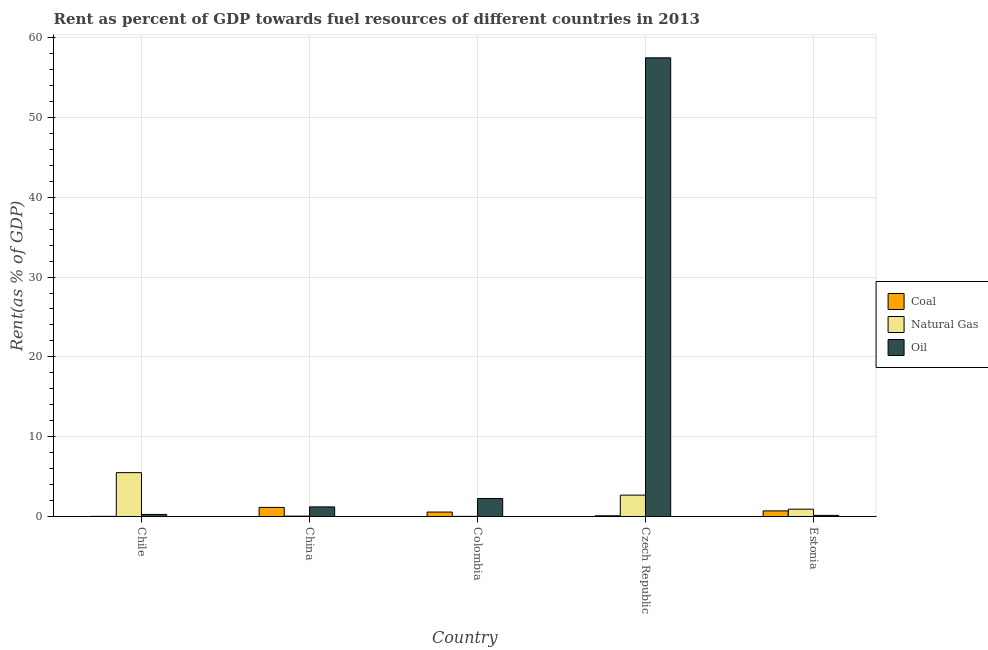How many groups of bars are there?
Your answer should be compact. 5. Are the number of bars per tick equal to the number of legend labels?
Your answer should be compact. Yes. Are the number of bars on each tick of the X-axis equal?
Your response must be concise. Yes. How many bars are there on the 4th tick from the left?
Your answer should be very brief. 3. How many bars are there on the 5th tick from the right?
Your response must be concise. 3. What is the label of the 1st group of bars from the left?
Your answer should be compact. Chile. In how many cases, is the number of bars for a given country not equal to the number of legend labels?
Your response must be concise. 0. What is the rent towards oil in Chile?
Give a very brief answer. 0.26. Across all countries, what is the maximum rent towards natural gas?
Your answer should be very brief. 5.5. Across all countries, what is the minimum rent towards coal?
Keep it short and to the point. 0.02. In which country was the rent towards oil maximum?
Provide a succinct answer. Czech Republic. In which country was the rent towards oil minimum?
Ensure brevity in your answer.  Estonia. What is the total rent towards coal in the graph?
Keep it short and to the point. 2.5. What is the difference between the rent towards oil in Colombia and that in Estonia?
Your response must be concise. 2.12. What is the difference between the rent towards natural gas in China and the rent towards oil in Colombia?
Ensure brevity in your answer.  -2.21. What is the average rent towards natural gas per country?
Ensure brevity in your answer.  1.83. What is the difference between the rent towards coal and rent towards oil in Colombia?
Ensure brevity in your answer.  -1.7. What is the ratio of the rent towards natural gas in China to that in Estonia?
Offer a terse response. 0.05. Is the rent towards oil in Czech Republic less than that in Estonia?
Ensure brevity in your answer.  No. What is the difference between the highest and the second highest rent towards natural gas?
Give a very brief answer. 2.82. What is the difference between the highest and the lowest rent towards oil?
Provide a short and direct response. 57.33. Is the sum of the rent towards oil in Chile and China greater than the maximum rent towards natural gas across all countries?
Offer a very short reply. No. What does the 2nd bar from the left in Chile represents?
Your answer should be compact. Natural Gas. What does the 2nd bar from the right in Estonia represents?
Ensure brevity in your answer.  Natural Gas. Is it the case that in every country, the sum of the rent towards coal and rent towards natural gas is greater than the rent towards oil?
Provide a short and direct response. No. What is the difference between two consecutive major ticks on the Y-axis?
Your response must be concise. 10. Are the values on the major ticks of Y-axis written in scientific E-notation?
Ensure brevity in your answer.  No. Does the graph contain any zero values?
Your answer should be very brief. No. Does the graph contain grids?
Your answer should be compact. Yes. Where does the legend appear in the graph?
Offer a terse response. Center right. How are the legend labels stacked?
Offer a terse response. Vertical. What is the title of the graph?
Keep it short and to the point. Rent as percent of GDP towards fuel resources of different countries in 2013. Does "Domestic economy" appear as one of the legend labels in the graph?
Your response must be concise. No. What is the label or title of the Y-axis?
Your answer should be very brief. Rent(as % of GDP). What is the Rent(as % of GDP) in Coal in Chile?
Provide a short and direct response. 0.02. What is the Rent(as % of GDP) of Natural Gas in Chile?
Make the answer very short. 5.5. What is the Rent(as % of GDP) in Oil in Chile?
Ensure brevity in your answer.  0.26. What is the Rent(as % of GDP) in Coal in China?
Your answer should be very brief. 1.14. What is the Rent(as % of GDP) of Natural Gas in China?
Offer a terse response. 0.05. What is the Rent(as % of GDP) of Oil in China?
Offer a very short reply. 1.2. What is the Rent(as % of GDP) in Coal in Colombia?
Provide a short and direct response. 0.56. What is the Rent(as % of GDP) of Natural Gas in Colombia?
Keep it short and to the point. 0.02. What is the Rent(as % of GDP) in Oil in Colombia?
Your answer should be compact. 2.26. What is the Rent(as % of GDP) of Coal in Czech Republic?
Provide a succinct answer. 0.09. What is the Rent(as % of GDP) of Natural Gas in Czech Republic?
Provide a succinct answer. 2.68. What is the Rent(as % of GDP) of Oil in Czech Republic?
Keep it short and to the point. 57.47. What is the Rent(as % of GDP) of Coal in Estonia?
Offer a terse response. 0.7. What is the Rent(as % of GDP) in Natural Gas in Estonia?
Your response must be concise. 0.92. What is the Rent(as % of GDP) in Oil in Estonia?
Provide a succinct answer. 0.14. Across all countries, what is the maximum Rent(as % of GDP) in Coal?
Your answer should be compact. 1.14. Across all countries, what is the maximum Rent(as % of GDP) of Natural Gas?
Your response must be concise. 5.5. Across all countries, what is the maximum Rent(as % of GDP) of Oil?
Provide a succinct answer. 57.47. Across all countries, what is the minimum Rent(as % of GDP) of Coal?
Give a very brief answer. 0.02. Across all countries, what is the minimum Rent(as % of GDP) of Natural Gas?
Provide a succinct answer. 0.02. Across all countries, what is the minimum Rent(as % of GDP) of Oil?
Keep it short and to the point. 0.14. What is the total Rent(as % of GDP) in Coal in the graph?
Offer a very short reply. 2.5. What is the total Rent(as % of GDP) of Natural Gas in the graph?
Give a very brief answer. 9.15. What is the total Rent(as % of GDP) in Oil in the graph?
Provide a short and direct response. 61.33. What is the difference between the Rent(as % of GDP) in Coal in Chile and that in China?
Offer a terse response. -1.12. What is the difference between the Rent(as % of GDP) of Natural Gas in Chile and that in China?
Your answer should be compact. 5.45. What is the difference between the Rent(as % of GDP) in Oil in Chile and that in China?
Offer a very short reply. -0.95. What is the difference between the Rent(as % of GDP) of Coal in Chile and that in Colombia?
Provide a succinct answer. -0.54. What is the difference between the Rent(as % of GDP) in Natural Gas in Chile and that in Colombia?
Give a very brief answer. 5.48. What is the difference between the Rent(as % of GDP) of Oil in Chile and that in Colombia?
Provide a short and direct response. -2. What is the difference between the Rent(as % of GDP) in Coal in Chile and that in Czech Republic?
Provide a succinct answer. -0.07. What is the difference between the Rent(as % of GDP) in Natural Gas in Chile and that in Czech Republic?
Provide a succinct answer. 2.82. What is the difference between the Rent(as % of GDP) of Oil in Chile and that in Czech Republic?
Offer a terse response. -57.22. What is the difference between the Rent(as % of GDP) in Coal in Chile and that in Estonia?
Provide a short and direct response. -0.68. What is the difference between the Rent(as % of GDP) in Natural Gas in Chile and that in Estonia?
Offer a terse response. 4.58. What is the difference between the Rent(as % of GDP) in Oil in Chile and that in Estonia?
Your answer should be compact. 0.12. What is the difference between the Rent(as % of GDP) in Coal in China and that in Colombia?
Your response must be concise. 0.58. What is the difference between the Rent(as % of GDP) of Natural Gas in China and that in Colombia?
Ensure brevity in your answer.  0.03. What is the difference between the Rent(as % of GDP) of Oil in China and that in Colombia?
Offer a very short reply. -1.05. What is the difference between the Rent(as % of GDP) of Coal in China and that in Czech Republic?
Make the answer very short. 1.05. What is the difference between the Rent(as % of GDP) of Natural Gas in China and that in Czech Republic?
Offer a very short reply. -2.63. What is the difference between the Rent(as % of GDP) in Oil in China and that in Czech Republic?
Offer a very short reply. -56.27. What is the difference between the Rent(as % of GDP) in Coal in China and that in Estonia?
Provide a short and direct response. 0.44. What is the difference between the Rent(as % of GDP) of Natural Gas in China and that in Estonia?
Give a very brief answer. -0.87. What is the difference between the Rent(as % of GDP) of Oil in China and that in Estonia?
Make the answer very short. 1.06. What is the difference between the Rent(as % of GDP) in Coal in Colombia and that in Czech Republic?
Your answer should be compact. 0.47. What is the difference between the Rent(as % of GDP) in Natural Gas in Colombia and that in Czech Republic?
Your answer should be compact. -2.66. What is the difference between the Rent(as % of GDP) in Oil in Colombia and that in Czech Republic?
Your answer should be very brief. -55.22. What is the difference between the Rent(as % of GDP) of Coal in Colombia and that in Estonia?
Provide a short and direct response. -0.14. What is the difference between the Rent(as % of GDP) of Natural Gas in Colombia and that in Estonia?
Provide a short and direct response. -0.9. What is the difference between the Rent(as % of GDP) of Oil in Colombia and that in Estonia?
Offer a terse response. 2.12. What is the difference between the Rent(as % of GDP) of Coal in Czech Republic and that in Estonia?
Provide a short and direct response. -0.61. What is the difference between the Rent(as % of GDP) of Natural Gas in Czech Republic and that in Estonia?
Offer a terse response. 1.76. What is the difference between the Rent(as % of GDP) in Oil in Czech Republic and that in Estonia?
Provide a short and direct response. 57.33. What is the difference between the Rent(as % of GDP) in Coal in Chile and the Rent(as % of GDP) in Natural Gas in China?
Your response must be concise. -0.03. What is the difference between the Rent(as % of GDP) in Coal in Chile and the Rent(as % of GDP) in Oil in China?
Offer a terse response. -1.19. What is the difference between the Rent(as % of GDP) in Natural Gas in Chile and the Rent(as % of GDP) in Oil in China?
Ensure brevity in your answer.  4.29. What is the difference between the Rent(as % of GDP) of Coal in Chile and the Rent(as % of GDP) of Oil in Colombia?
Ensure brevity in your answer.  -2.24. What is the difference between the Rent(as % of GDP) of Natural Gas in Chile and the Rent(as % of GDP) of Oil in Colombia?
Your answer should be very brief. 3.24. What is the difference between the Rent(as % of GDP) of Coal in Chile and the Rent(as % of GDP) of Natural Gas in Czech Republic?
Provide a succinct answer. -2.66. What is the difference between the Rent(as % of GDP) in Coal in Chile and the Rent(as % of GDP) in Oil in Czech Republic?
Provide a succinct answer. -57.46. What is the difference between the Rent(as % of GDP) in Natural Gas in Chile and the Rent(as % of GDP) in Oil in Czech Republic?
Provide a short and direct response. -51.98. What is the difference between the Rent(as % of GDP) of Coal in Chile and the Rent(as % of GDP) of Natural Gas in Estonia?
Your response must be concise. -0.9. What is the difference between the Rent(as % of GDP) of Coal in Chile and the Rent(as % of GDP) of Oil in Estonia?
Offer a terse response. -0.12. What is the difference between the Rent(as % of GDP) of Natural Gas in Chile and the Rent(as % of GDP) of Oil in Estonia?
Ensure brevity in your answer.  5.36. What is the difference between the Rent(as % of GDP) in Coal in China and the Rent(as % of GDP) in Natural Gas in Colombia?
Make the answer very short. 1.12. What is the difference between the Rent(as % of GDP) of Coal in China and the Rent(as % of GDP) of Oil in Colombia?
Make the answer very short. -1.12. What is the difference between the Rent(as % of GDP) of Natural Gas in China and the Rent(as % of GDP) of Oil in Colombia?
Your response must be concise. -2.21. What is the difference between the Rent(as % of GDP) in Coal in China and the Rent(as % of GDP) in Natural Gas in Czech Republic?
Offer a very short reply. -1.54. What is the difference between the Rent(as % of GDP) of Coal in China and the Rent(as % of GDP) of Oil in Czech Republic?
Your response must be concise. -56.34. What is the difference between the Rent(as % of GDP) of Natural Gas in China and the Rent(as % of GDP) of Oil in Czech Republic?
Provide a succinct answer. -57.43. What is the difference between the Rent(as % of GDP) in Coal in China and the Rent(as % of GDP) in Natural Gas in Estonia?
Provide a short and direct response. 0.22. What is the difference between the Rent(as % of GDP) of Natural Gas in China and the Rent(as % of GDP) of Oil in Estonia?
Your answer should be compact. -0.09. What is the difference between the Rent(as % of GDP) in Coal in Colombia and the Rent(as % of GDP) in Natural Gas in Czech Republic?
Your answer should be compact. -2.12. What is the difference between the Rent(as % of GDP) in Coal in Colombia and the Rent(as % of GDP) in Oil in Czech Republic?
Your response must be concise. -56.92. What is the difference between the Rent(as % of GDP) of Natural Gas in Colombia and the Rent(as % of GDP) of Oil in Czech Republic?
Your response must be concise. -57.46. What is the difference between the Rent(as % of GDP) in Coal in Colombia and the Rent(as % of GDP) in Natural Gas in Estonia?
Provide a succinct answer. -0.36. What is the difference between the Rent(as % of GDP) in Coal in Colombia and the Rent(as % of GDP) in Oil in Estonia?
Make the answer very short. 0.42. What is the difference between the Rent(as % of GDP) in Natural Gas in Colombia and the Rent(as % of GDP) in Oil in Estonia?
Your response must be concise. -0.12. What is the difference between the Rent(as % of GDP) of Coal in Czech Republic and the Rent(as % of GDP) of Natural Gas in Estonia?
Your response must be concise. -0.83. What is the difference between the Rent(as % of GDP) of Coal in Czech Republic and the Rent(as % of GDP) of Oil in Estonia?
Offer a very short reply. -0.05. What is the difference between the Rent(as % of GDP) in Natural Gas in Czech Republic and the Rent(as % of GDP) in Oil in Estonia?
Offer a very short reply. 2.54. What is the average Rent(as % of GDP) of Coal per country?
Ensure brevity in your answer.  0.5. What is the average Rent(as % of GDP) of Natural Gas per country?
Give a very brief answer. 1.83. What is the average Rent(as % of GDP) in Oil per country?
Your answer should be compact. 12.27. What is the difference between the Rent(as % of GDP) of Coal and Rent(as % of GDP) of Natural Gas in Chile?
Offer a very short reply. -5.48. What is the difference between the Rent(as % of GDP) of Coal and Rent(as % of GDP) of Oil in Chile?
Make the answer very short. -0.24. What is the difference between the Rent(as % of GDP) in Natural Gas and Rent(as % of GDP) in Oil in Chile?
Offer a very short reply. 5.24. What is the difference between the Rent(as % of GDP) of Coal and Rent(as % of GDP) of Natural Gas in China?
Give a very brief answer. 1.09. What is the difference between the Rent(as % of GDP) of Coal and Rent(as % of GDP) of Oil in China?
Your answer should be very brief. -0.07. What is the difference between the Rent(as % of GDP) of Natural Gas and Rent(as % of GDP) of Oil in China?
Provide a succinct answer. -1.16. What is the difference between the Rent(as % of GDP) in Coal and Rent(as % of GDP) in Natural Gas in Colombia?
Ensure brevity in your answer.  0.54. What is the difference between the Rent(as % of GDP) of Coal and Rent(as % of GDP) of Oil in Colombia?
Your response must be concise. -1.7. What is the difference between the Rent(as % of GDP) of Natural Gas and Rent(as % of GDP) of Oil in Colombia?
Ensure brevity in your answer.  -2.24. What is the difference between the Rent(as % of GDP) of Coal and Rent(as % of GDP) of Natural Gas in Czech Republic?
Your response must be concise. -2.59. What is the difference between the Rent(as % of GDP) of Coal and Rent(as % of GDP) of Oil in Czech Republic?
Your answer should be compact. -57.39. What is the difference between the Rent(as % of GDP) of Natural Gas and Rent(as % of GDP) of Oil in Czech Republic?
Provide a short and direct response. -54.8. What is the difference between the Rent(as % of GDP) in Coal and Rent(as % of GDP) in Natural Gas in Estonia?
Provide a succinct answer. -0.22. What is the difference between the Rent(as % of GDP) in Coal and Rent(as % of GDP) in Oil in Estonia?
Give a very brief answer. 0.56. What is the difference between the Rent(as % of GDP) of Natural Gas and Rent(as % of GDP) of Oil in Estonia?
Your answer should be compact. 0.78. What is the ratio of the Rent(as % of GDP) in Coal in Chile to that in China?
Ensure brevity in your answer.  0.01. What is the ratio of the Rent(as % of GDP) of Natural Gas in Chile to that in China?
Provide a short and direct response. 116.85. What is the ratio of the Rent(as % of GDP) in Oil in Chile to that in China?
Your answer should be compact. 0.21. What is the ratio of the Rent(as % of GDP) of Coal in Chile to that in Colombia?
Your response must be concise. 0.03. What is the ratio of the Rent(as % of GDP) of Natural Gas in Chile to that in Colombia?
Your response must be concise. 351.25. What is the ratio of the Rent(as % of GDP) of Oil in Chile to that in Colombia?
Offer a terse response. 0.11. What is the ratio of the Rent(as % of GDP) of Coal in Chile to that in Czech Republic?
Offer a very short reply. 0.18. What is the ratio of the Rent(as % of GDP) in Natural Gas in Chile to that in Czech Republic?
Offer a very short reply. 2.05. What is the ratio of the Rent(as % of GDP) of Oil in Chile to that in Czech Republic?
Keep it short and to the point. 0. What is the ratio of the Rent(as % of GDP) of Coal in Chile to that in Estonia?
Keep it short and to the point. 0.02. What is the ratio of the Rent(as % of GDP) of Natural Gas in Chile to that in Estonia?
Make the answer very short. 5.99. What is the ratio of the Rent(as % of GDP) of Oil in Chile to that in Estonia?
Offer a terse response. 1.85. What is the ratio of the Rent(as % of GDP) in Coal in China to that in Colombia?
Provide a succinct answer. 2.05. What is the ratio of the Rent(as % of GDP) in Natural Gas in China to that in Colombia?
Provide a short and direct response. 3.01. What is the ratio of the Rent(as % of GDP) of Oil in China to that in Colombia?
Keep it short and to the point. 0.53. What is the ratio of the Rent(as % of GDP) in Coal in China to that in Czech Republic?
Give a very brief answer. 12.82. What is the ratio of the Rent(as % of GDP) in Natural Gas in China to that in Czech Republic?
Your answer should be compact. 0.02. What is the ratio of the Rent(as % of GDP) in Oil in China to that in Czech Republic?
Your answer should be very brief. 0.02. What is the ratio of the Rent(as % of GDP) of Coal in China to that in Estonia?
Your response must be concise. 1.63. What is the ratio of the Rent(as % of GDP) in Natural Gas in China to that in Estonia?
Offer a very short reply. 0.05. What is the ratio of the Rent(as % of GDP) of Oil in China to that in Estonia?
Your answer should be very brief. 8.65. What is the ratio of the Rent(as % of GDP) of Coal in Colombia to that in Czech Republic?
Provide a short and direct response. 6.26. What is the ratio of the Rent(as % of GDP) in Natural Gas in Colombia to that in Czech Republic?
Offer a very short reply. 0.01. What is the ratio of the Rent(as % of GDP) of Oil in Colombia to that in Czech Republic?
Give a very brief answer. 0.04. What is the ratio of the Rent(as % of GDP) in Coal in Colombia to that in Estonia?
Offer a very short reply. 0.79. What is the ratio of the Rent(as % of GDP) of Natural Gas in Colombia to that in Estonia?
Offer a very short reply. 0.02. What is the ratio of the Rent(as % of GDP) of Oil in Colombia to that in Estonia?
Offer a terse response. 16.19. What is the ratio of the Rent(as % of GDP) in Coal in Czech Republic to that in Estonia?
Provide a succinct answer. 0.13. What is the ratio of the Rent(as % of GDP) of Natural Gas in Czech Republic to that in Estonia?
Keep it short and to the point. 2.92. What is the ratio of the Rent(as % of GDP) of Oil in Czech Republic to that in Estonia?
Your answer should be compact. 412.69. What is the difference between the highest and the second highest Rent(as % of GDP) of Coal?
Your answer should be compact. 0.44. What is the difference between the highest and the second highest Rent(as % of GDP) of Natural Gas?
Your response must be concise. 2.82. What is the difference between the highest and the second highest Rent(as % of GDP) in Oil?
Make the answer very short. 55.22. What is the difference between the highest and the lowest Rent(as % of GDP) in Coal?
Your response must be concise. 1.12. What is the difference between the highest and the lowest Rent(as % of GDP) of Natural Gas?
Your answer should be very brief. 5.48. What is the difference between the highest and the lowest Rent(as % of GDP) of Oil?
Provide a succinct answer. 57.33. 